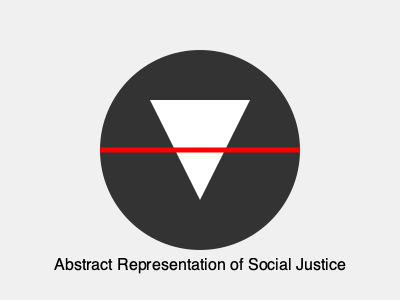Analyze the artistic elements in this abstract representation of social justice. Which artistic movement does this piece most closely align with, and how does it convey its message? 1. Composition: The image is centered and symmetrical, with a circle as the main focal point. This suggests balance and unity, common in many abstract art movements.

2. Shapes: The use of basic geometric shapes (circle, triangle, line) is reminiscent of Constructivism and Suprematism, art movements that often dealt with social and political themes.

3. Colors: The limited color palette of black, white, and red is striking and symbolic. Black and white often represent opposing forces or concepts, while red frequently symbolizes revolution or urgent change in social justice contexts.

4. Symbolism: The white triangle within the black circle could represent hope or progress emerging from darkness or oppression. The red line cutting through the composition might symbolize division or the need to break through barriers.

5. Style: The overall minimalist and geometric approach aligns closely with the Russian Constructivist movement of the early 20th century. This movement often used art as a tool for social change and to convey political messages.

6. Message: Through its stark contrasts and simple yet powerful imagery, the piece conveys a sense of struggle, division, and the potential for change – all central themes in social justice art.

Given these elements, the piece most closely aligns with Constructivism, an artistic and architectural movement that emerged in Russia around 1915. Constructivism often rejected "art for art's sake" in favor of art as a practice directed towards social purposes, making it particularly relevant for social justice themes.
Answer: Constructivism 